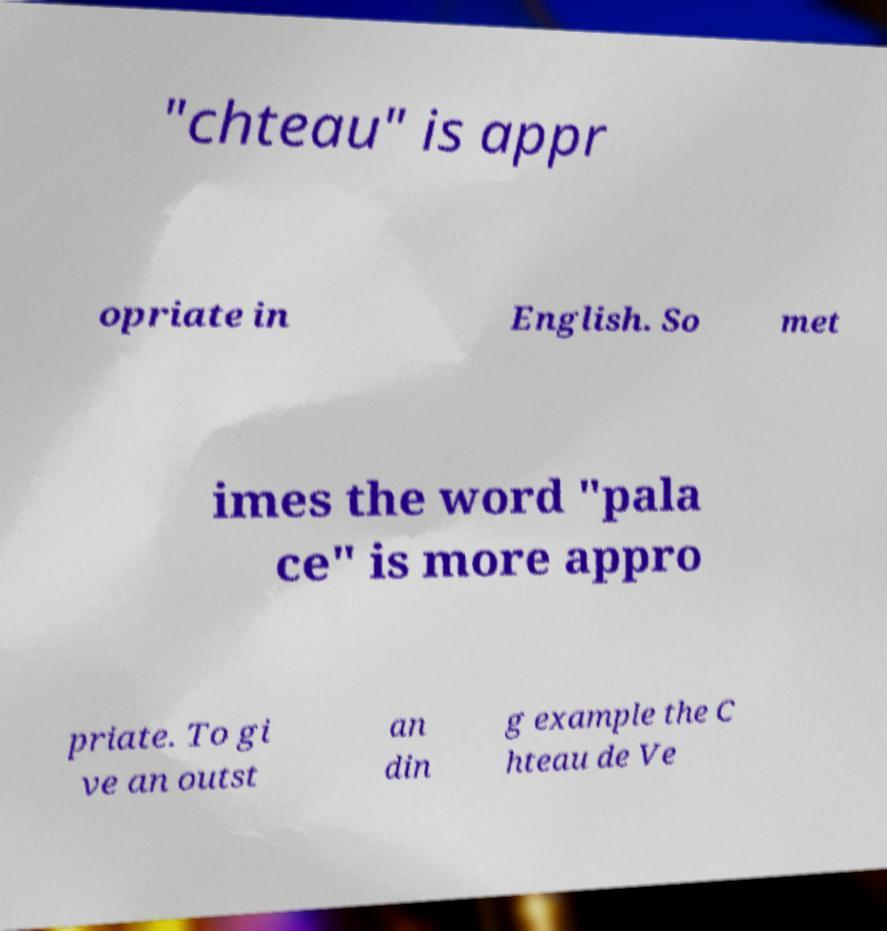For documentation purposes, I need the text within this image transcribed. Could you provide that? "chteau" is appr opriate in English. So met imes the word "pala ce" is more appro priate. To gi ve an outst an din g example the C hteau de Ve 